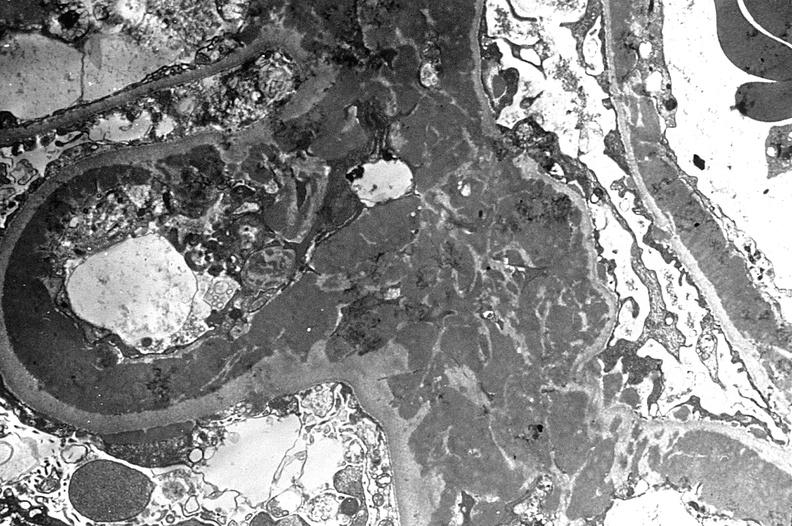what is present?
Answer the question using a single word or phrase. Urinary 